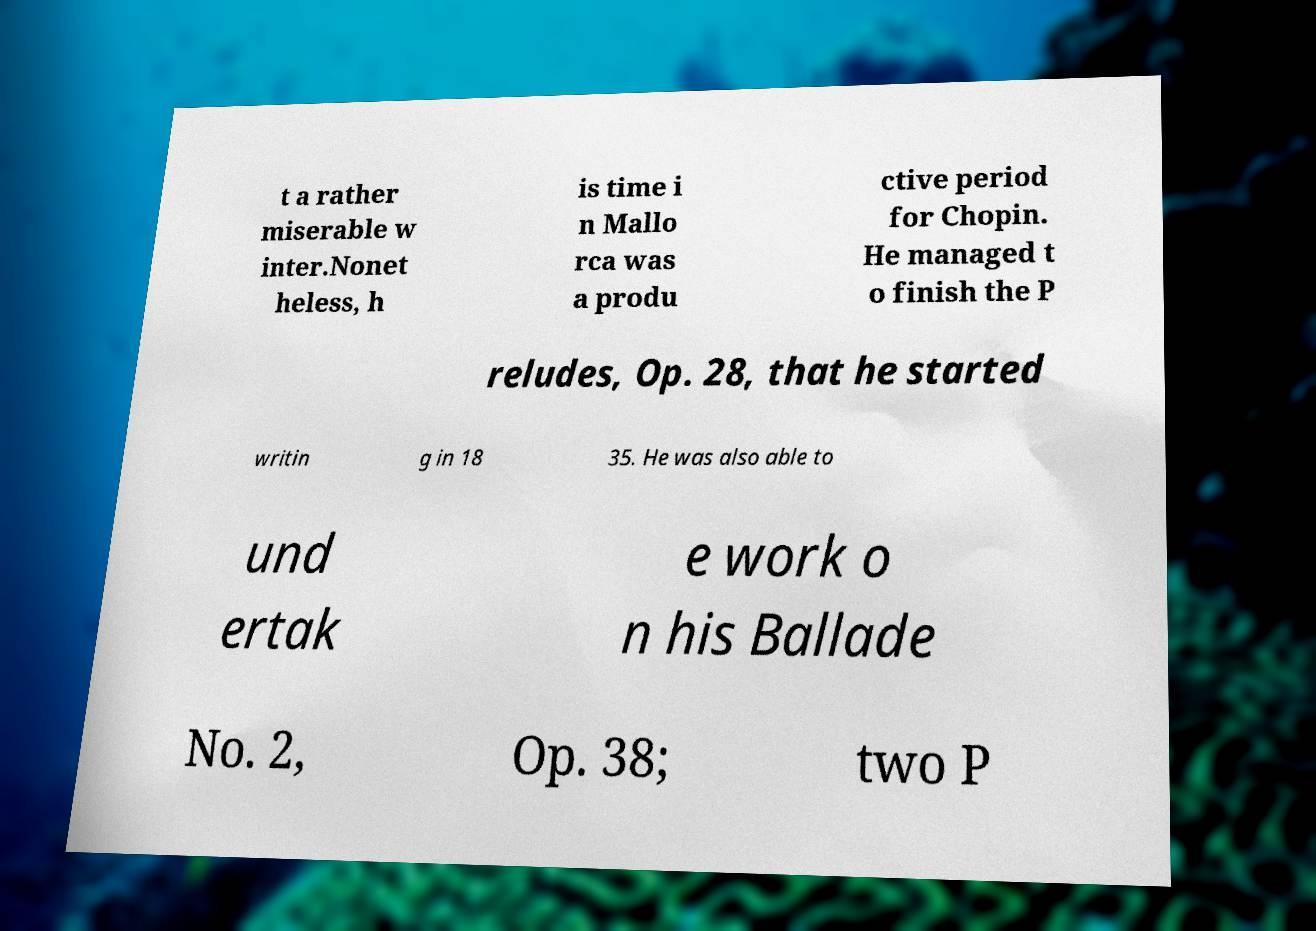I need the written content from this picture converted into text. Can you do that? t a rather miserable w inter.Nonet heless, h is time i n Mallo rca was a produ ctive period for Chopin. He managed t o finish the P reludes, Op. 28, that he started writin g in 18 35. He was also able to und ertak e work o n his Ballade No. 2, Op. 38; two P 